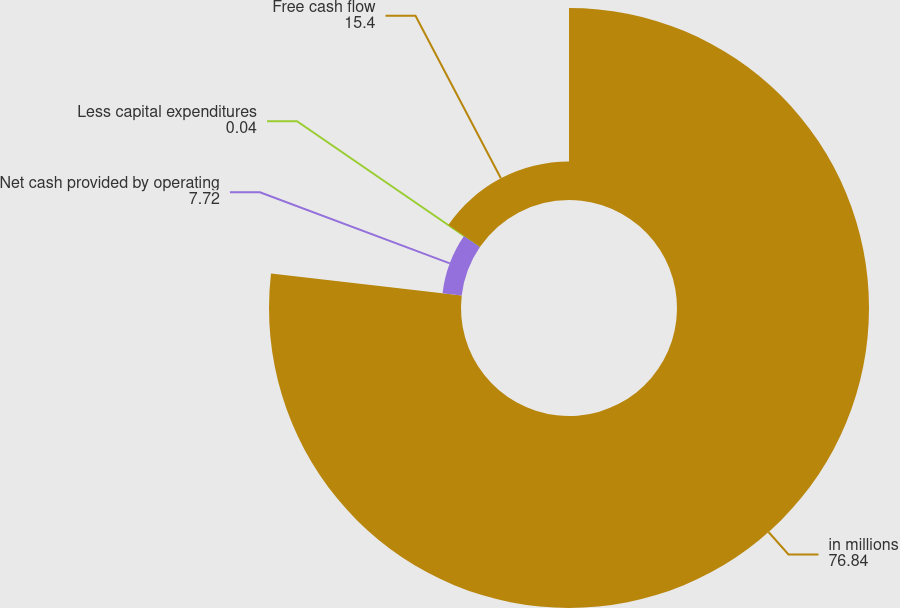<chart> <loc_0><loc_0><loc_500><loc_500><pie_chart><fcel>in millions<fcel>Net cash provided by operating<fcel>Less capital expenditures<fcel>Free cash flow<nl><fcel>76.84%<fcel>7.72%<fcel>0.04%<fcel>15.4%<nl></chart> 